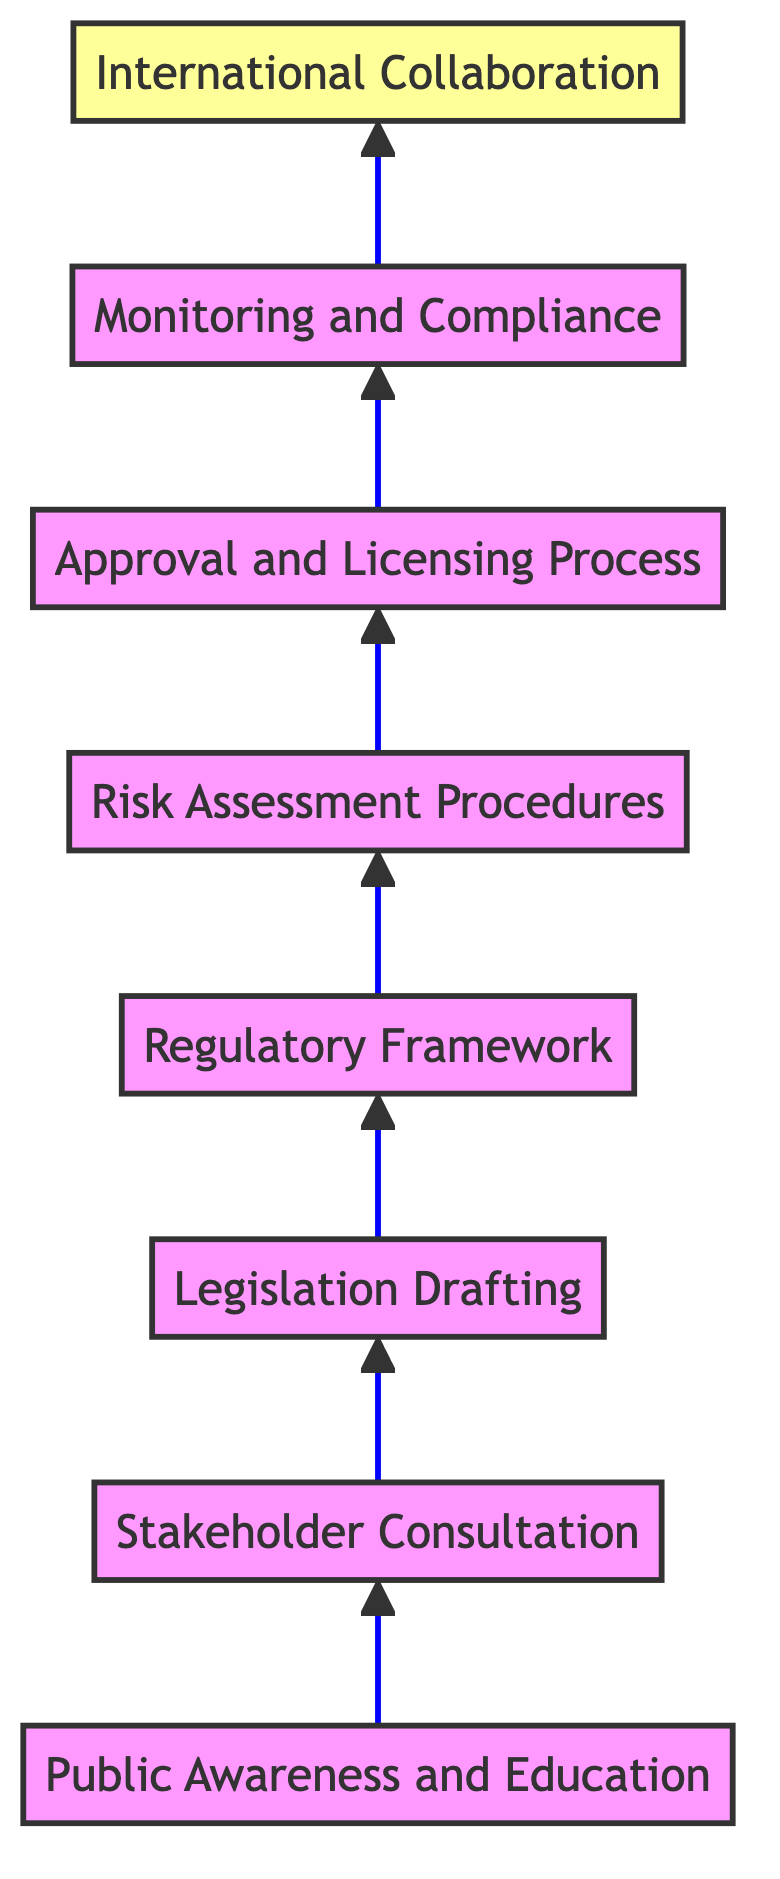What is the first node in the flow chart? The first node in the flow chart is "Public Awareness and Education", which is located at the bottom.
Answer: Public Awareness and Education How many nodes are present in the diagram? To find the total number of nodes, we can count all unique stages described in the flowchart, resulting in eight distinct nodes.
Answer: 8 What is the last node in the flow chart? The last node in the flow chart is "International Collaboration", which is positioned at the top of the chart.
Answer: International Collaboration Which node immediately follows "Regulatory Framework"? Following "Regulatory Framework", the next node is "Risk Assessment Procedures". This is determined by observing the direct connection in the flow from one node to the next.
Answer: Risk Assessment Procedures What is the relationship between "Stakeholder Consultation" and "Legislation Drafting"? "Stakeholder Consultation" leads to "Legislation Drafting", meaning the output of the consultation process directly contributes to drafting the legislation.
Answer: leads to What is the relationship between the final node and the first node? The final node "International Collaboration" connects back to the entire flow initiated by "Public Awareness and Education", indicating a comprehensive process leading to harmonization of global standards.
Answer: Comprehensive process How many edges are in the diagram? Each connection between nodes represents an edge, and by counting the connections from the flowchart, we find that there are seven edges linking the eight nodes.
Answer: 7 What is the node connected to "Approval and Licensing Process"? "Approval and Licensing Process" is directly connected to "Monitoring and Compliance", showing the progression from approval to ongoing supervision.
Answer: Monitoring and Compliance Which nodes are positioned directly above "Risk Assessment Procedures"? Directly above "Risk Assessment Procedures" is "Regulatory Framework", indicating the hierarchy of steps from regulation to assessment.
Answer: Regulatory Framework What type of flow does this diagram represent? This diagram represents a bottom-to-top flow, indicating a structured approach where processes build on one another from education to international collaboration.
Answer: Bottom-to-top flow 